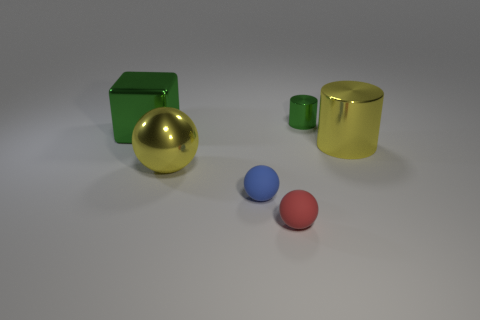Is the shape of the large green thing the same as the small green object?
Ensure brevity in your answer.  No. What is the shape of the yellow thing in front of the big object to the right of the tiny blue sphere?
Give a very brief answer. Sphere. Are there any blue rubber objects?
Your answer should be compact. Yes. How many blue rubber spheres are in front of the large yellow object that is in front of the big yellow thing that is behind the large ball?
Give a very brief answer. 1. There is a blue thing; is its shape the same as the yellow metallic thing left of the tiny green metallic cylinder?
Offer a very short reply. Yes. Are there more large yellow cylinders than purple balls?
Offer a terse response. Yes. Are there any other things that are the same size as the yellow ball?
Keep it short and to the point. Yes. There is a green metallic object to the left of the large yellow sphere; is its shape the same as the small red matte thing?
Make the answer very short. No. Are there more green metallic objects that are left of the yellow ball than large brown metal balls?
Provide a short and direct response. Yes. There is a thing on the left side of the yellow thing left of the blue object; what color is it?
Provide a succinct answer. Green. 